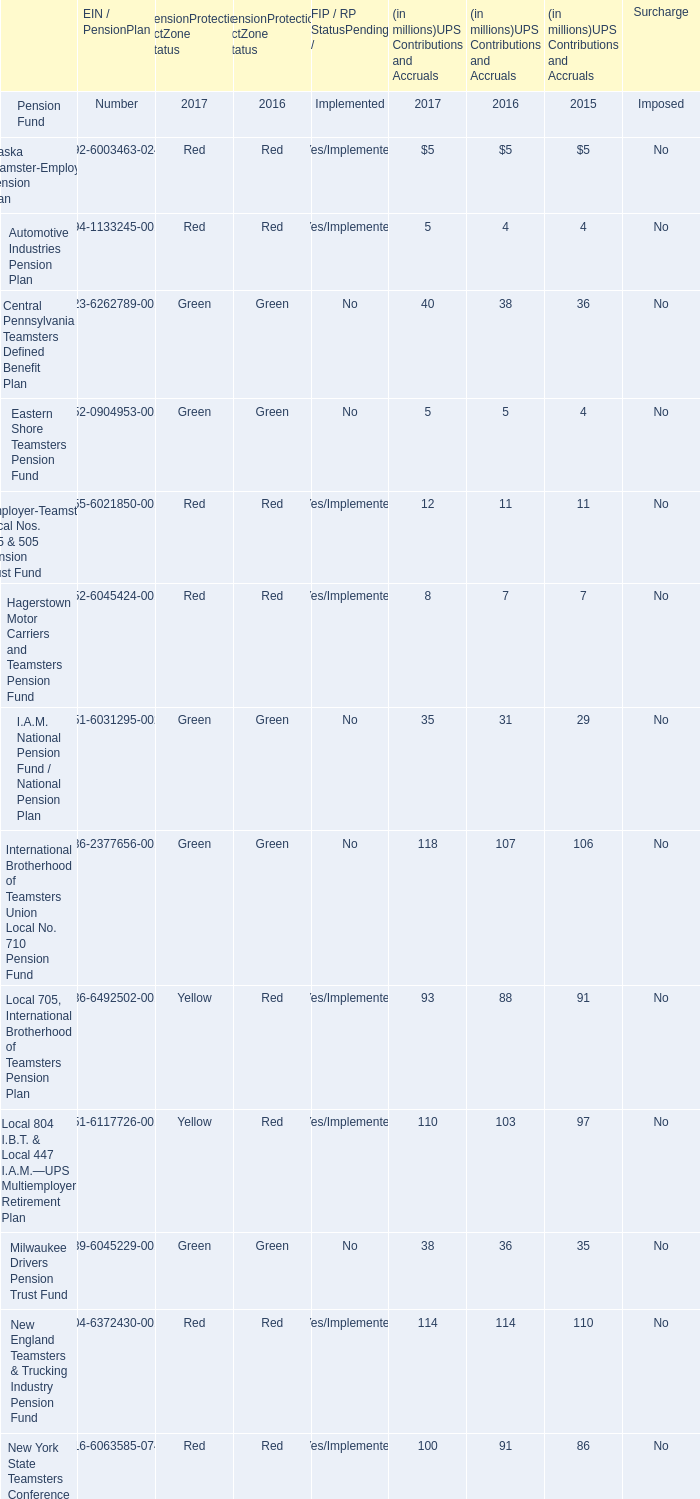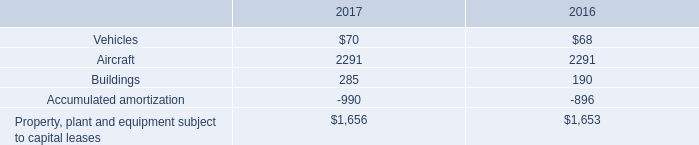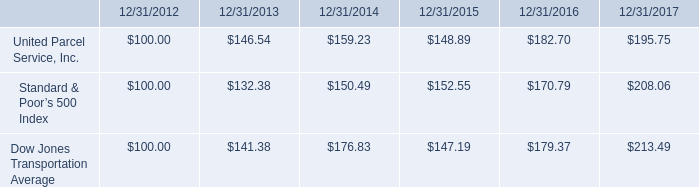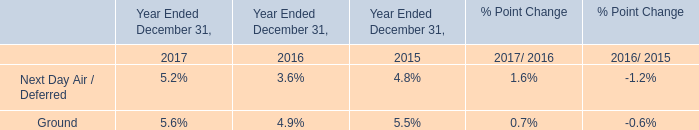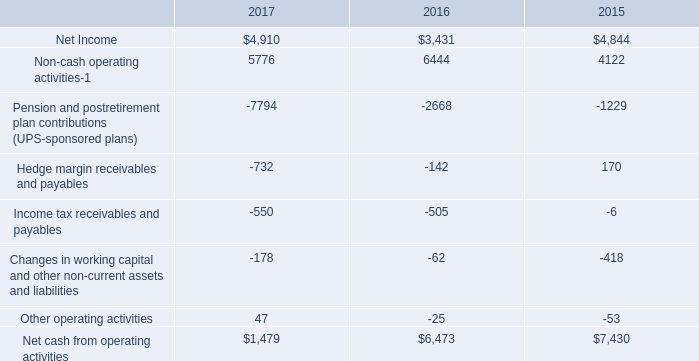Which year is the value of UPS Contributions and Accruals for Eastern Shore Teamsters Pension Fund the lowest? 
Answer: 2015. 